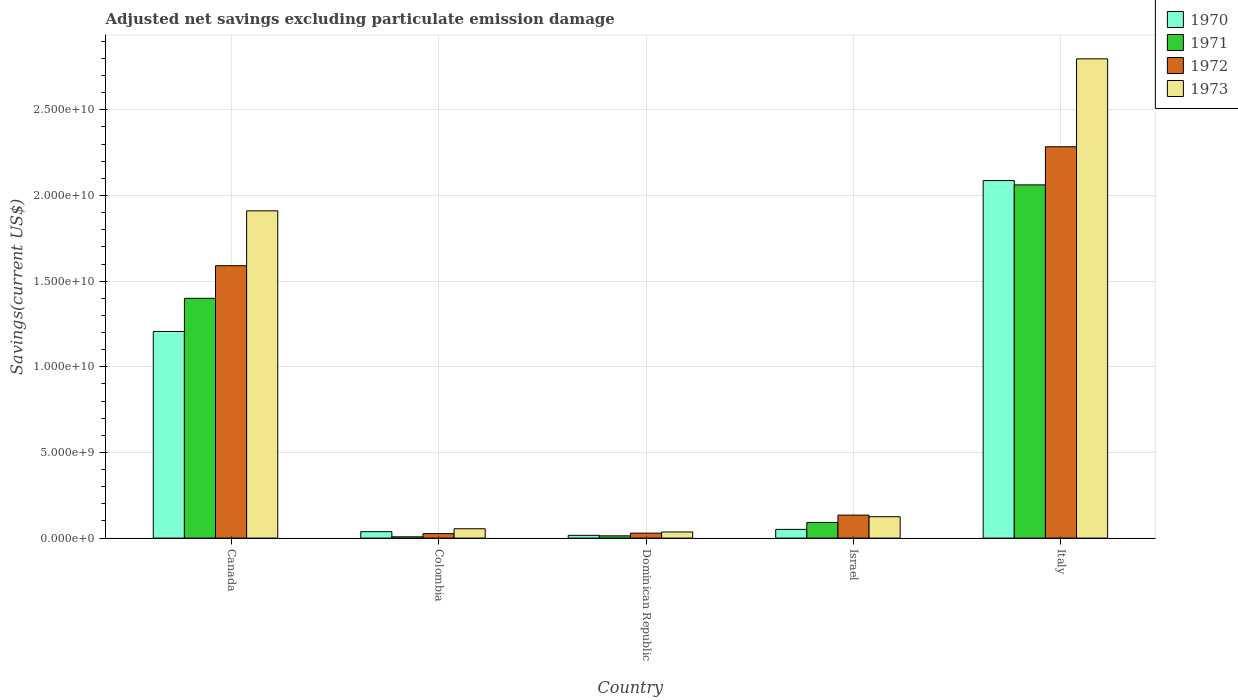How many different coloured bars are there?
Give a very brief answer. 4. How many groups of bars are there?
Provide a short and direct response. 5. Are the number of bars per tick equal to the number of legend labels?
Provide a succinct answer. Yes. Are the number of bars on each tick of the X-axis equal?
Keep it short and to the point. Yes. How many bars are there on the 4th tick from the left?
Offer a terse response. 4. How many bars are there on the 5th tick from the right?
Offer a terse response. 4. In how many cases, is the number of bars for a given country not equal to the number of legend labels?
Offer a very short reply. 0. What is the adjusted net savings in 1973 in Canada?
Give a very brief answer. 1.91e+1. Across all countries, what is the maximum adjusted net savings in 1971?
Make the answer very short. 2.06e+1. Across all countries, what is the minimum adjusted net savings in 1972?
Give a very brief answer. 2.60e+08. In which country was the adjusted net savings in 1973 minimum?
Your answer should be very brief. Dominican Republic. What is the total adjusted net savings in 1970 in the graph?
Your response must be concise. 3.40e+1. What is the difference between the adjusted net savings in 1970 in Dominican Republic and that in Italy?
Give a very brief answer. -2.07e+1. What is the difference between the adjusted net savings in 1971 in Colombia and the adjusted net savings in 1970 in Italy?
Ensure brevity in your answer.  -2.08e+1. What is the average adjusted net savings in 1970 per country?
Provide a succinct answer. 6.80e+09. What is the difference between the adjusted net savings of/in 1972 and adjusted net savings of/in 1970 in Dominican Republic?
Give a very brief answer. 1.28e+08. What is the ratio of the adjusted net savings in 1972 in Canada to that in Israel?
Make the answer very short. 11.86. Is the adjusted net savings in 1972 in Colombia less than that in Israel?
Offer a very short reply. Yes. Is the difference between the adjusted net savings in 1972 in Colombia and Dominican Republic greater than the difference between the adjusted net savings in 1970 in Colombia and Dominican Republic?
Provide a succinct answer. No. What is the difference between the highest and the second highest adjusted net savings in 1972?
Keep it short and to the point. -2.15e+1. What is the difference between the highest and the lowest adjusted net savings in 1971?
Make the answer very short. 2.05e+1. Is it the case that in every country, the sum of the adjusted net savings in 1971 and adjusted net savings in 1972 is greater than the sum of adjusted net savings in 1970 and adjusted net savings in 1973?
Ensure brevity in your answer.  No. What does the 4th bar from the right in Colombia represents?
Your answer should be very brief. 1970. Is it the case that in every country, the sum of the adjusted net savings in 1972 and adjusted net savings in 1973 is greater than the adjusted net savings in 1970?
Make the answer very short. Yes. How many bars are there?
Your answer should be compact. 20. Are the values on the major ticks of Y-axis written in scientific E-notation?
Keep it short and to the point. Yes. Does the graph contain any zero values?
Offer a terse response. No. How are the legend labels stacked?
Your answer should be very brief. Vertical. What is the title of the graph?
Give a very brief answer. Adjusted net savings excluding particulate emission damage. What is the label or title of the Y-axis?
Ensure brevity in your answer.  Savings(current US$). What is the Savings(current US$) of 1970 in Canada?
Provide a short and direct response. 1.21e+1. What is the Savings(current US$) of 1971 in Canada?
Keep it short and to the point. 1.40e+1. What is the Savings(current US$) in 1972 in Canada?
Your answer should be very brief. 1.59e+1. What is the Savings(current US$) of 1973 in Canada?
Give a very brief answer. 1.91e+1. What is the Savings(current US$) in 1970 in Colombia?
Offer a very short reply. 3.74e+08. What is the Savings(current US$) of 1971 in Colombia?
Provide a short and direct response. 7.46e+07. What is the Savings(current US$) in 1972 in Colombia?
Your answer should be very brief. 2.60e+08. What is the Savings(current US$) in 1973 in Colombia?
Ensure brevity in your answer.  5.45e+08. What is the Savings(current US$) in 1970 in Dominican Republic?
Your response must be concise. 1.61e+08. What is the Savings(current US$) in 1971 in Dominican Republic?
Your response must be concise. 1.32e+08. What is the Savings(current US$) in 1972 in Dominican Republic?
Your response must be concise. 2.89e+08. What is the Savings(current US$) in 1973 in Dominican Republic?
Provide a succinct answer. 3.58e+08. What is the Savings(current US$) in 1970 in Israel?
Give a very brief answer. 5.08e+08. What is the Savings(current US$) of 1971 in Israel?
Ensure brevity in your answer.  9.14e+08. What is the Savings(current US$) in 1972 in Israel?
Ensure brevity in your answer.  1.34e+09. What is the Savings(current US$) in 1973 in Israel?
Your answer should be very brief. 1.25e+09. What is the Savings(current US$) in 1970 in Italy?
Your answer should be very brief. 2.09e+1. What is the Savings(current US$) of 1971 in Italy?
Provide a succinct answer. 2.06e+1. What is the Savings(current US$) in 1972 in Italy?
Offer a terse response. 2.28e+1. What is the Savings(current US$) of 1973 in Italy?
Your response must be concise. 2.80e+1. Across all countries, what is the maximum Savings(current US$) in 1970?
Your answer should be compact. 2.09e+1. Across all countries, what is the maximum Savings(current US$) of 1971?
Your response must be concise. 2.06e+1. Across all countries, what is the maximum Savings(current US$) of 1972?
Offer a very short reply. 2.28e+1. Across all countries, what is the maximum Savings(current US$) of 1973?
Your answer should be very brief. 2.80e+1. Across all countries, what is the minimum Savings(current US$) in 1970?
Provide a short and direct response. 1.61e+08. Across all countries, what is the minimum Savings(current US$) in 1971?
Provide a short and direct response. 7.46e+07. Across all countries, what is the minimum Savings(current US$) of 1972?
Your answer should be compact. 2.60e+08. Across all countries, what is the minimum Savings(current US$) in 1973?
Provide a succinct answer. 3.58e+08. What is the total Savings(current US$) of 1970 in the graph?
Your answer should be very brief. 3.40e+1. What is the total Savings(current US$) in 1971 in the graph?
Make the answer very short. 3.57e+1. What is the total Savings(current US$) in 1972 in the graph?
Provide a short and direct response. 4.06e+1. What is the total Savings(current US$) in 1973 in the graph?
Your answer should be compact. 4.92e+1. What is the difference between the Savings(current US$) of 1970 in Canada and that in Colombia?
Ensure brevity in your answer.  1.17e+1. What is the difference between the Savings(current US$) of 1971 in Canada and that in Colombia?
Provide a succinct answer. 1.39e+1. What is the difference between the Savings(current US$) in 1972 in Canada and that in Colombia?
Your answer should be very brief. 1.56e+1. What is the difference between the Savings(current US$) of 1973 in Canada and that in Colombia?
Ensure brevity in your answer.  1.86e+1. What is the difference between the Savings(current US$) in 1970 in Canada and that in Dominican Republic?
Offer a very short reply. 1.19e+1. What is the difference between the Savings(current US$) of 1971 in Canada and that in Dominican Republic?
Keep it short and to the point. 1.39e+1. What is the difference between the Savings(current US$) in 1972 in Canada and that in Dominican Republic?
Ensure brevity in your answer.  1.56e+1. What is the difference between the Savings(current US$) of 1973 in Canada and that in Dominican Republic?
Your answer should be very brief. 1.87e+1. What is the difference between the Savings(current US$) of 1970 in Canada and that in Israel?
Your answer should be compact. 1.16e+1. What is the difference between the Savings(current US$) in 1971 in Canada and that in Israel?
Ensure brevity in your answer.  1.31e+1. What is the difference between the Savings(current US$) of 1972 in Canada and that in Israel?
Ensure brevity in your answer.  1.46e+1. What is the difference between the Savings(current US$) of 1973 in Canada and that in Israel?
Make the answer very short. 1.79e+1. What is the difference between the Savings(current US$) of 1970 in Canada and that in Italy?
Your answer should be compact. -8.81e+09. What is the difference between the Savings(current US$) of 1971 in Canada and that in Italy?
Give a very brief answer. -6.62e+09. What is the difference between the Savings(current US$) in 1972 in Canada and that in Italy?
Offer a terse response. -6.94e+09. What is the difference between the Savings(current US$) in 1973 in Canada and that in Italy?
Provide a succinct answer. -8.87e+09. What is the difference between the Savings(current US$) in 1970 in Colombia and that in Dominican Republic?
Offer a terse response. 2.13e+08. What is the difference between the Savings(current US$) in 1971 in Colombia and that in Dominican Republic?
Your answer should be very brief. -5.69e+07. What is the difference between the Savings(current US$) of 1972 in Colombia and that in Dominican Republic?
Your answer should be compact. -2.84e+07. What is the difference between the Savings(current US$) in 1973 in Colombia and that in Dominican Republic?
Ensure brevity in your answer.  1.87e+08. What is the difference between the Savings(current US$) in 1970 in Colombia and that in Israel?
Provide a short and direct response. -1.34e+08. What is the difference between the Savings(current US$) of 1971 in Colombia and that in Israel?
Ensure brevity in your answer.  -8.40e+08. What is the difference between the Savings(current US$) in 1972 in Colombia and that in Israel?
Your answer should be compact. -1.08e+09. What is the difference between the Savings(current US$) of 1973 in Colombia and that in Israel?
Your answer should be very brief. -7.02e+08. What is the difference between the Savings(current US$) in 1970 in Colombia and that in Italy?
Provide a short and direct response. -2.05e+1. What is the difference between the Savings(current US$) in 1971 in Colombia and that in Italy?
Your answer should be compact. -2.05e+1. What is the difference between the Savings(current US$) of 1972 in Colombia and that in Italy?
Give a very brief answer. -2.26e+1. What is the difference between the Savings(current US$) in 1973 in Colombia and that in Italy?
Your answer should be compact. -2.74e+1. What is the difference between the Savings(current US$) of 1970 in Dominican Republic and that in Israel?
Your answer should be compact. -3.47e+08. What is the difference between the Savings(current US$) in 1971 in Dominican Republic and that in Israel?
Your answer should be compact. -7.83e+08. What is the difference between the Savings(current US$) in 1972 in Dominican Republic and that in Israel?
Provide a succinct answer. -1.05e+09. What is the difference between the Savings(current US$) in 1973 in Dominican Republic and that in Israel?
Offer a very short reply. -8.89e+08. What is the difference between the Savings(current US$) in 1970 in Dominican Republic and that in Italy?
Keep it short and to the point. -2.07e+1. What is the difference between the Savings(current US$) of 1971 in Dominican Republic and that in Italy?
Provide a short and direct response. -2.05e+1. What is the difference between the Savings(current US$) of 1972 in Dominican Republic and that in Italy?
Make the answer very short. -2.26e+1. What is the difference between the Savings(current US$) of 1973 in Dominican Republic and that in Italy?
Ensure brevity in your answer.  -2.76e+1. What is the difference between the Savings(current US$) of 1970 in Israel and that in Italy?
Your answer should be compact. -2.04e+1. What is the difference between the Savings(current US$) in 1971 in Israel and that in Italy?
Provide a succinct answer. -1.97e+1. What is the difference between the Savings(current US$) of 1972 in Israel and that in Italy?
Ensure brevity in your answer.  -2.15e+1. What is the difference between the Savings(current US$) in 1973 in Israel and that in Italy?
Offer a very short reply. -2.67e+1. What is the difference between the Savings(current US$) of 1970 in Canada and the Savings(current US$) of 1971 in Colombia?
Your answer should be very brief. 1.20e+1. What is the difference between the Savings(current US$) in 1970 in Canada and the Savings(current US$) in 1972 in Colombia?
Keep it short and to the point. 1.18e+1. What is the difference between the Savings(current US$) of 1970 in Canada and the Savings(current US$) of 1973 in Colombia?
Provide a short and direct response. 1.15e+1. What is the difference between the Savings(current US$) in 1971 in Canada and the Savings(current US$) in 1972 in Colombia?
Give a very brief answer. 1.37e+1. What is the difference between the Savings(current US$) in 1971 in Canada and the Savings(current US$) in 1973 in Colombia?
Offer a very short reply. 1.35e+1. What is the difference between the Savings(current US$) in 1972 in Canada and the Savings(current US$) in 1973 in Colombia?
Ensure brevity in your answer.  1.54e+1. What is the difference between the Savings(current US$) in 1970 in Canada and the Savings(current US$) in 1971 in Dominican Republic?
Your response must be concise. 1.19e+1. What is the difference between the Savings(current US$) in 1970 in Canada and the Savings(current US$) in 1972 in Dominican Republic?
Provide a short and direct response. 1.18e+1. What is the difference between the Savings(current US$) in 1970 in Canada and the Savings(current US$) in 1973 in Dominican Republic?
Make the answer very short. 1.17e+1. What is the difference between the Savings(current US$) of 1971 in Canada and the Savings(current US$) of 1972 in Dominican Republic?
Offer a terse response. 1.37e+1. What is the difference between the Savings(current US$) of 1971 in Canada and the Savings(current US$) of 1973 in Dominican Republic?
Keep it short and to the point. 1.36e+1. What is the difference between the Savings(current US$) of 1972 in Canada and the Savings(current US$) of 1973 in Dominican Republic?
Ensure brevity in your answer.  1.55e+1. What is the difference between the Savings(current US$) in 1970 in Canada and the Savings(current US$) in 1971 in Israel?
Provide a succinct answer. 1.11e+1. What is the difference between the Savings(current US$) of 1970 in Canada and the Savings(current US$) of 1972 in Israel?
Your answer should be very brief. 1.07e+1. What is the difference between the Savings(current US$) of 1970 in Canada and the Savings(current US$) of 1973 in Israel?
Your response must be concise. 1.08e+1. What is the difference between the Savings(current US$) of 1971 in Canada and the Savings(current US$) of 1972 in Israel?
Your response must be concise. 1.27e+1. What is the difference between the Savings(current US$) in 1971 in Canada and the Savings(current US$) in 1973 in Israel?
Keep it short and to the point. 1.27e+1. What is the difference between the Savings(current US$) of 1972 in Canada and the Savings(current US$) of 1973 in Israel?
Provide a succinct answer. 1.47e+1. What is the difference between the Savings(current US$) of 1970 in Canada and the Savings(current US$) of 1971 in Italy?
Give a very brief answer. -8.56e+09. What is the difference between the Savings(current US$) in 1970 in Canada and the Savings(current US$) in 1972 in Italy?
Your answer should be very brief. -1.08e+1. What is the difference between the Savings(current US$) of 1970 in Canada and the Savings(current US$) of 1973 in Italy?
Offer a terse response. -1.59e+1. What is the difference between the Savings(current US$) in 1971 in Canada and the Savings(current US$) in 1972 in Italy?
Give a very brief answer. -8.85e+09. What is the difference between the Savings(current US$) in 1971 in Canada and the Savings(current US$) in 1973 in Italy?
Your response must be concise. -1.40e+1. What is the difference between the Savings(current US$) in 1972 in Canada and the Savings(current US$) in 1973 in Italy?
Offer a very short reply. -1.21e+1. What is the difference between the Savings(current US$) in 1970 in Colombia and the Savings(current US$) in 1971 in Dominican Republic?
Your answer should be very brief. 2.42e+08. What is the difference between the Savings(current US$) in 1970 in Colombia and the Savings(current US$) in 1972 in Dominican Republic?
Your answer should be compact. 8.52e+07. What is the difference between the Savings(current US$) of 1970 in Colombia and the Savings(current US$) of 1973 in Dominican Republic?
Offer a terse response. 1.57e+07. What is the difference between the Savings(current US$) in 1971 in Colombia and the Savings(current US$) in 1972 in Dominican Republic?
Your answer should be very brief. -2.14e+08. What is the difference between the Savings(current US$) in 1971 in Colombia and the Savings(current US$) in 1973 in Dominican Republic?
Make the answer very short. -2.84e+08. What is the difference between the Savings(current US$) in 1972 in Colombia and the Savings(current US$) in 1973 in Dominican Republic?
Make the answer very short. -9.79e+07. What is the difference between the Savings(current US$) in 1970 in Colombia and the Savings(current US$) in 1971 in Israel?
Your answer should be compact. -5.40e+08. What is the difference between the Savings(current US$) of 1970 in Colombia and the Savings(current US$) of 1972 in Israel?
Offer a very short reply. -9.67e+08. What is the difference between the Savings(current US$) in 1970 in Colombia and the Savings(current US$) in 1973 in Israel?
Your response must be concise. -8.73e+08. What is the difference between the Savings(current US$) of 1971 in Colombia and the Savings(current US$) of 1972 in Israel?
Ensure brevity in your answer.  -1.27e+09. What is the difference between the Savings(current US$) in 1971 in Colombia and the Savings(current US$) in 1973 in Israel?
Give a very brief answer. -1.17e+09. What is the difference between the Savings(current US$) in 1972 in Colombia and the Savings(current US$) in 1973 in Israel?
Make the answer very short. -9.87e+08. What is the difference between the Savings(current US$) of 1970 in Colombia and the Savings(current US$) of 1971 in Italy?
Ensure brevity in your answer.  -2.02e+1. What is the difference between the Savings(current US$) in 1970 in Colombia and the Savings(current US$) in 1972 in Italy?
Keep it short and to the point. -2.25e+1. What is the difference between the Savings(current US$) in 1970 in Colombia and the Savings(current US$) in 1973 in Italy?
Your response must be concise. -2.76e+1. What is the difference between the Savings(current US$) of 1971 in Colombia and the Savings(current US$) of 1972 in Italy?
Your answer should be very brief. -2.28e+1. What is the difference between the Savings(current US$) in 1971 in Colombia and the Savings(current US$) in 1973 in Italy?
Keep it short and to the point. -2.79e+1. What is the difference between the Savings(current US$) in 1972 in Colombia and the Savings(current US$) in 1973 in Italy?
Ensure brevity in your answer.  -2.77e+1. What is the difference between the Savings(current US$) of 1970 in Dominican Republic and the Savings(current US$) of 1971 in Israel?
Make the answer very short. -7.53e+08. What is the difference between the Savings(current US$) of 1970 in Dominican Republic and the Savings(current US$) of 1972 in Israel?
Offer a very short reply. -1.18e+09. What is the difference between the Savings(current US$) of 1970 in Dominican Republic and the Savings(current US$) of 1973 in Israel?
Offer a terse response. -1.09e+09. What is the difference between the Savings(current US$) in 1971 in Dominican Republic and the Savings(current US$) in 1972 in Israel?
Offer a terse response. -1.21e+09. What is the difference between the Savings(current US$) in 1971 in Dominican Republic and the Savings(current US$) in 1973 in Israel?
Give a very brief answer. -1.12e+09. What is the difference between the Savings(current US$) of 1972 in Dominican Republic and the Savings(current US$) of 1973 in Israel?
Keep it short and to the point. -9.58e+08. What is the difference between the Savings(current US$) of 1970 in Dominican Republic and the Savings(current US$) of 1971 in Italy?
Ensure brevity in your answer.  -2.05e+1. What is the difference between the Savings(current US$) of 1970 in Dominican Republic and the Savings(current US$) of 1972 in Italy?
Provide a short and direct response. -2.27e+1. What is the difference between the Savings(current US$) of 1970 in Dominican Republic and the Savings(current US$) of 1973 in Italy?
Your response must be concise. -2.78e+1. What is the difference between the Savings(current US$) in 1971 in Dominican Republic and the Savings(current US$) in 1972 in Italy?
Your answer should be very brief. -2.27e+1. What is the difference between the Savings(current US$) of 1971 in Dominican Republic and the Savings(current US$) of 1973 in Italy?
Ensure brevity in your answer.  -2.78e+1. What is the difference between the Savings(current US$) of 1972 in Dominican Republic and the Savings(current US$) of 1973 in Italy?
Ensure brevity in your answer.  -2.77e+1. What is the difference between the Savings(current US$) of 1970 in Israel and the Savings(current US$) of 1971 in Italy?
Your answer should be very brief. -2.01e+1. What is the difference between the Savings(current US$) in 1970 in Israel and the Savings(current US$) in 1972 in Italy?
Provide a short and direct response. -2.23e+1. What is the difference between the Savings(current US$) in 1970 in Israel and the Savings(current US$) in 1973 in Italy?
Your answer should be very brief. -2.75e+1. What is the difference between the Savings(current US$) in 1971 in Israel and the Savings(current US$) in 1972 in Italy?
Provide a succinct answer. -2.19e+1. What is the difference between the Savings(current US$) of 1971 in Israel and the Savings(current US$) of 1973 in Italy?
Provide a succinct answer. -2.71e+1. What is the difference between the Savings(current US$) in 1972 in Israel and the Savings(current US$) in 1973 in Italy?
Your response must be concise. -2.66e+1. What is the average Savings(current US$) of 1970 per country?
Your response must be concise. 6.80e+09. What is the average Savings(current US$) of 1971 per country?
Provide a succinct answer. 7.15e+09. What is the average Savings(current US$) in 1972 per country?
Offer a terse response. 8.13e+09. What is the average Savings(current US$) of 1973 per country?
Your answer should be very brief. 9.85e+09. What is the difference between the Savings(current US$) in 1970 and Savings(current US$) in 1971 in Canada?
Ensure brevity in your answer.  -1.94e+09. What is the difference between the Savings(current US$) of 1970 and Savings(current US$) of 1972 in Canada?
Your answer should be compact. -3.84e+09. What is the difference between the Savings(current US$) in 1970 and Savings(current US$) in 1973 in Canada?
Provide a succinct answer. -7.04e+09. What is the difference between the Savings(current US$) in 1971 and Savings(current US$) in 1972 in Canada?
Offer a terse response. -1.90e+09. What is the difference between the Savings(current US$) in 1971 and Savings(current US$) in 1973 in Canada?
Provide a short and direct response. -5.11e+09. What is the difference between the Savings(current US$) of 1972 and Savings(current US$) of 1973 in Canada?
Ensure brevity in your answer.  -3.20e+09. What is the difference between the Savings(current US$) in 1970 and Savings(current US$) in 1971 in Colombia?
Make the answer very short. 2.99e+08. What is the difference between the Savings(current US$) of 1970 and Savings(current US$) of 1972 in Colombia?
Offer a terse response. 1.14e+08. What is the difference between the Savings(current US$) of 1970 and Savings(current US$) of 1973 in Colombia?
Make the answer very short. -1.71e+08. What is the difference between the Savings(current US$) of 1971 and Savings(current US$) of 1972 in Colombia?
Offer a terse response. -1.86e+08. What is the difference between the Savings(current US$) of 1971 and Savings(current US$) of 1973 in Colombia?
Keep it short and to the point. -4.70e+08. What is the difference between the Savings(current US$) in 1972 and Savings(current US$) in 1973 in Colombia?
Provide a short and direct response. -2.85e+08. What is the difference between the Savings(current US$) of 1970 and Savings(current US$) of 1971 in Dominican Republic?
Keep it short and to the point. 2.96e+07. What is the difference between the Savings(current US$) in 1970 and Savings(current US$) in 1972 in Dominican Republic?
Keep it short and to the point. -1.28e+08. What is the difference between the Savings(current US$) of 1970 and Savings(current US$) of 1973 in Dominican Republic?
Ensure brevity in your answer.  -1.97e+08. What is the difference between the Savings(current US$) in 1971 and Savings(current US$) in 1972 in Dominican Republic?
Ensure brevity in your answer.  -1.57e+08. What is the difference between the Savings(current US$) of 1971 and Savings(current US$) of 1973 in Dominican Republic?
Provide a short and direct response. -2.27e+08. What is the difference between the Savings(current US$) of 1972 and Savings(current US$) of 1973 in Dominican Republic?
Ensure brevity in your answer.  -6.95e+07. What is the difference between the Savings(current US$) of 1970 and Savings(current US$) of 1971 in Israel?
Offer a very short reply. -4.06e+08. What is the difference between the Savings(current US$) of 1970 and Savings(current US$) of 1972 in Israel?
Offer a very short reply. -8.33e+08. What is the difference between the Savings(current US$) of 1970 and Savings(current US$) of 1973 in Israel?
Give a very brief answer. -7.39e+08. What is the difference between the Savings(current US$) of 1971 and Savings(current US$) of 1972 in Israel?
Ensure brevity in your answer.  -4.27e+08. What is the difference between the Savings(current US$) in 1971 and Savings(current US$) in 1973 in Israel?
Offer a very short reply. -3.33e+08. What is the difference between the Savings(current US$) in 1972 and Savings(current US$) in 1973 in Israel?
Keep it short and to the point. 9.40e+07. What is the difference between the Savings(current US$) of 1970 and Savings(current US$) of 1971 in Italy?
Your answer should be compact. 2.53e+08. What is the difference between the Savings(current US$) in 1970 and Savings(current US$) in 1972 in Italy?
Offer a very short reply. -1.97e+09. What is the difference between the Savings(current US$) of 1970 and Savings(current US$) of 1973 in Italy?
Your response must be concise. -7.11e+09. What is the difference between the Savings(current US$) of 1971 and Savings(current US$) of 1972 in Italy?
Ensure brevity in your answer.  -2.23e+09. What is the difference between the Savings(current US$) of 1971 and Savings(current US$) of 1973 in Italy?
Keep it short and to the point. -7.36e+09. What is the difference between the Savings(current US$) of 1972 and Savings(current US$) of 1973 in Italy?
Offer a terse response. -5.13e+09. What is the ratio of the Savings(current US$) in 1970 in Canada to that in Colombia?
Your response must be concise. 32.26. What is the ratio of the Savings(current US$) in 1971 in Canada to that in Colombia?
Keep it short and to the point. 187.59. What is the ratio of the Savings(current US$) in 1972 in Canada to that in Colombia?
Give a very brief answer. 61.09. What is the ratio of the Savings(current US$) of 1973 in Canada to that in Colombia?
Your answer should be very brief. 35.07. What is the ratio of the Savings(current US$) in 1970 in Canada to that in Dominican Republic?
Make the answer very short. 74.87. What is the ratio of the Savings(current US$) of 1971 in Canada to that in Dominican Republic?
Make the answer very short. 106.4. What is the ratio of the Savings(current US$) in 1972 in Canada to that in Dominican Republic?
Give a very brief answer. 55.08. What is the ratio of the Savings(current US$) in 1973 in Canada to that in Dominican Republic?
Provide a succinct answer. 53.33. What is the ratio of the Savings(current US$) of 1970 in Canada to that in Israel?
Your response must be concise. 23.75. What is the ratio of the Savings(current US$) in 1971 in Canada to that in Israel?
Give a very brief answer. 15.31. What is the ratio of the Savings(current US$) in 1972 in Canada to that in Israel?
Offer a terse response. 11.86. What is the ratio of the Savings(current US$) of 1973 in Canada to that in Israel?
Provide a succinct answer. 15.32. What is the ratio of the Savings(current US$) in 1970 in Canada to that in Italy?
Your response must be concise. 0.58. What is the ratio of the Savings(current US$) of 1971 in Canada to that in Italy?
Your answer should be very brief. 0.68. What is the ratio of the Savings(current US$) of 1972 in Canada to that in Italy?
Offer a terse response. 0.7. What is the ratio of the Savings(current US$) of 1973 in Canada to that in Italy?
Your answer should be compact. 0.68. What is the ratio of the Savings(current US$) in 1970 in Colombia to that in Dominican Republic?
Ensure brevity in your answer.  2.32. What is the ratio of the Savings(current US$) of 1971 in Colombia to that in Dominican Republic?
Your answer should be compact. 0.57. What is the ratio of the Savings(current US$) in 1972 in Colombia to that in Dominican Republic?
Your response must be concise. 0.9. What is the ratio of the Savings(current US$) of 1973 in Colombia to that in Dominican Republic?
Your answer should be very brief. 1.52. What is the ratio of the Savings(current US$) in 1970 in Colombia to that in Israel?
Offer a terse response. 0.74. What is the ratio of the Savings(current US$) in 1971 in Colombia to that in Israel?
Keep it short and to the point. 0.08. What is the ratio of the Savings(current US$) in 1972 in Colombia to that in Israel?
Your answer should be very brief. 0.19. What is the ratio of the Savings(current US$) in 1973 in Colombia to that in Israel?
Your response must be concise. 0.44. What is the ratio of the Savings(current US$) in 1970 in Colombia to that in Italy?
Your answer should be compact. 0.02. What is the ratio of the Savings(current US$) of 1971 in Colombia to that in Italy?
Provide a succinct answer. 0. What is the ratio of the Savings(current US$) of 1972 in Colombia to that in Italy?
Make the answer very short. 0.01. What is the ratio of the Savings(current US$) of 1973 in Colombia to that in Italy?
Your response must be concise. 0.02. What is the ratio of the Savings(current US$) of 1970 in Dominican Republic to that in Israel?
Give a very brief answer. 0.32. What is the ratio of the Savings(current US$) of 1971 in Dominican Republic to that in Israel?
Give a very brief answer. 0.14. What is the ratio of the Savings(current US$) in 1972 in Dominican Republic to that in Israel?
Keep it short and to the point. 0.22. What is the ratio of the Savings(current US$) of 1973 in Dominican Republic to that in Israel?
Ensure brevity in your answer.  0.29. What is the ratio of the Savings(current US$) in 1970 in Dominican Republic to that in Italy?
Keep it short and to the point. 0.01. What is the ratio of the Savings(current US$) in 1971 in Dominican Republic to that in Italy?
Ensure brevity in your answer.  0.01. What is the ratio of the Savings(current US$) of 1972 in Dominican Republic to that in Italy?
Offer a very short reply. 0.01. What is the ratio of the Savings(current US$) in 1973 in Dominican Republic to that in Italy?
Make the answer very short. 0.01. What is the ratio of the Savings(current US$) in 1970 in Israel to that in Italy?
Offer a very short reply. 0.02. What is the ratio of the Savings(current US$) of 1971 in Israel to that in Italy?
Your answer should be compact. 0.04. What is the ratio of the Savings(current US$) of 1972 in Israel to that in Italy?
Offer a terse response. 0.06. What is the ratio of the Savings(current US$) in 1973 in Israel to that in Italy?
Give a very brief answer. 0.04. What is the difference between the highest and the second highest Savings(current US$) of 1970?
Your answer should be compact. 8.81e+09. What is the difference between the highest and the second highest Savings(current US$) of 1971?
Give a very brief answer. 6.62e+09. What is the difference between the highest and the second highest Savings(current US$) of 1972?
Offer a terse response. 6.94e+09. What is the difference between the highest and the second highest Savings(current US$) of 1973?
Make the answer very short. 8.87e+09. What is the difference between the highest and the lowest Savings(current US$) of 1970?
Make the answer very short. 2.07e+1. What is the difference between the highest and the lowest Savings(current US$) in 1971?
Offer a very short reply. 2.05e+1. What is the difference between the highest and the lowest Savings(current US$) of 1972?
Make the answer very short. 2.26e+1. What is the difference between the highest and the lowest Savings(current US$) in 1973?
Offer a terse response. 2.76e+1. 